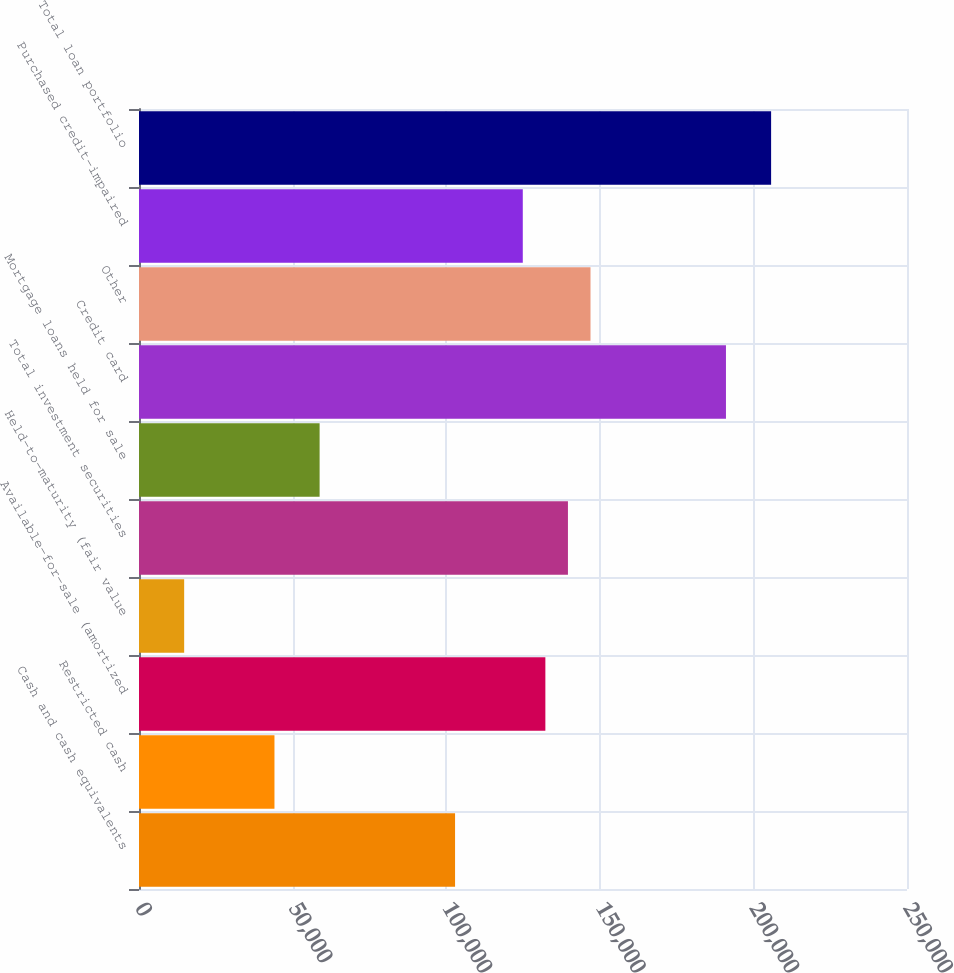Convert chart to OTSL. <chart><loc_0><loc_0><loc_500><loc_500><bar_chart><fcel>Cash and cash equivalents<fcel>Restricted cash<fcel>Available-for-sale (amortized<fcel>Held-to-maturity (fair value<fcel>Total investment securities<fcel>Mortgage loans held for sale<fcel>Credit card<fcel>Other<fcel>Purchased credit-impaired<fcel>Total loan portfolio<nl><fcel>102885<fcel>44096.6<fcel>132280<fcel>14702.2<fcel>139628<fcel>58793.8<fcel>191069<fcel>146977<fcel>124931<fcel>205766<nl></chart> 